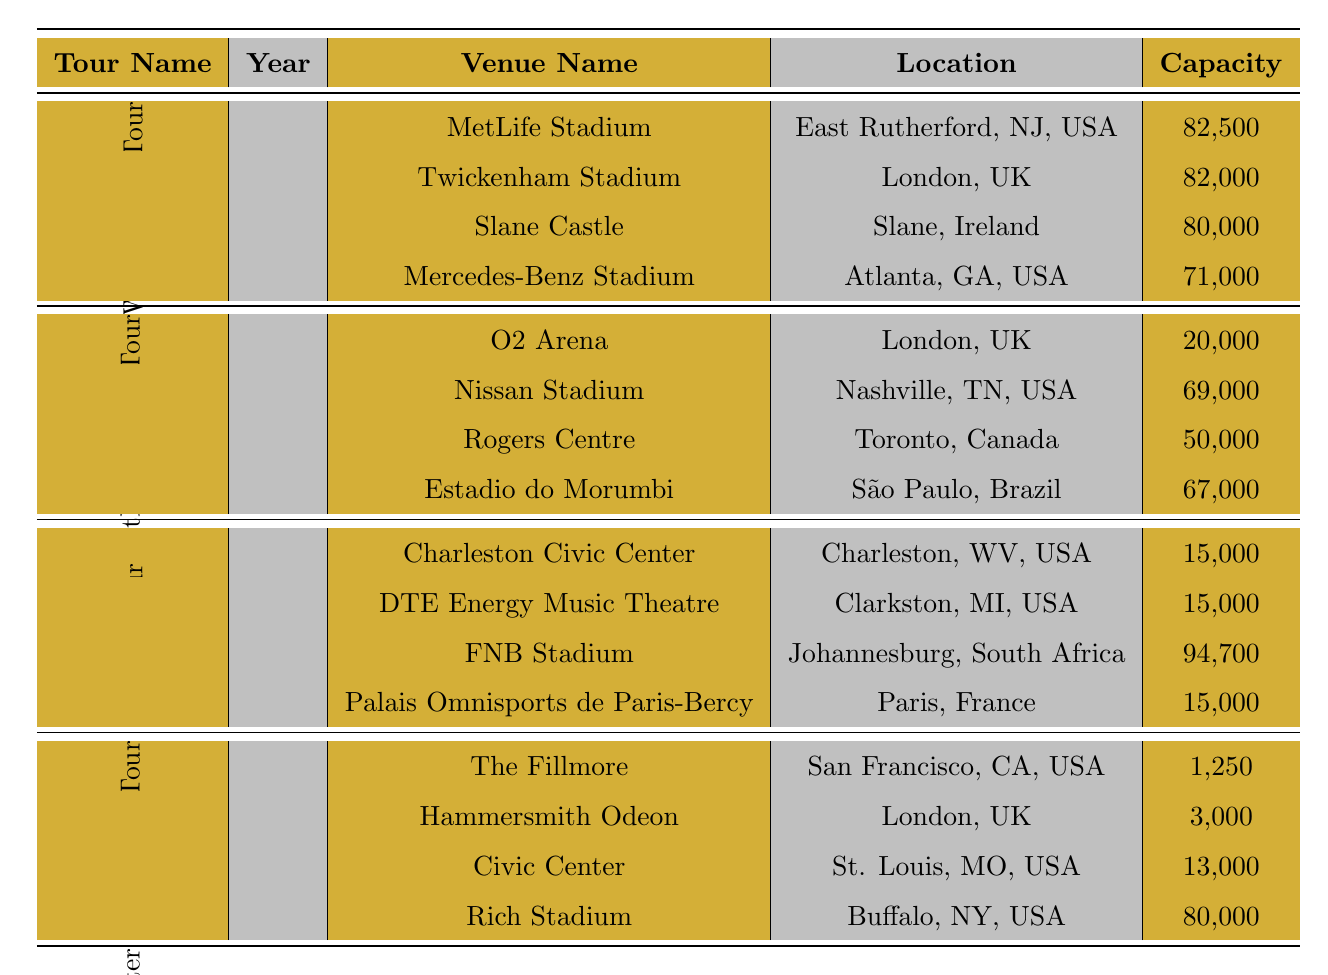What's the maximum venue capacity from the WorldWired Tour? The venues listed under the WorldWired Tour are MetLife Stadium (82,500), Twickenham Stadium (82,000), Slane Castle (80,000), and Mercedes-Benz Stadium (71,000). The highest capacity among these is MetLife Stadium at 82,500.
Answer: 82,500 Which tour had the least capacity at a single venue? The Master of Puppets Tour had The Fillmore with a capacity of 1,250, which is the lowest of all the venues listed in the table.
Answer: 1,250 What is the total capacity of all venues in the Death Magnetic Tour? The venues for the Death Magnetic Tour and their capacities are: O2 Arena (20,000), Nissan Stadium (69,000), Rogers Centre (50,000), and Estadio do Morumbi (67,000). Adding these values gives: 20,000 + 69,000 + 50,000 + 67,000 = 206,000.
Answer: 206,000 Is there a venue in the Load Tour that has a higher capacity than any venue in the Death Magnetic Tour? The highest capacity in the Load Tour is FNB Stadium at 94,700, which is greater than the highest capacity in the Death Magnetic Tour, which is Nissan Stadium at 69,000. Thus, yes, there is a venue in the Load Tour with a higher capacity.
Answer: Yes What is the average venue capacity across all tours listed? To find the average, first, we sum the capacities of all venues: 82,500 (WorldWired Tour) + 82,000 (WorldWired) + 80,000 (WorldWired) + 71,000 (WorldWired) + 20,000 (Death Magnetic) + 69,000 (Death Magnetic) + 50,000 (Death Magnetic) + 67,000 (Death Magnetic) + 15,000 (Load) + 15,000 (Load) + 94,700 (Load) + 15,000 (Load) + 1,250 (Master of Puppets) + 3,000 (Master of Puppets) + 13,000 (Master of Puppets) + 80,000 (Master of Puppets) = 670,450. There are 16 venues, so the average is 670,450 / 16 = 41,903.125, rounding down gives 41,903.
Answer: 41,903 Which city's venues had the highest capacities overall? In the list, San Francisco (The Fillmore at 1,250) is the lowest capacity, while FNB Stadium in Johannesburg has the highest capacity at 94,700 among other venues. However, New York (MetLife Stadium at 82,500) is also high. Since Johannesburg has the highest single venue capacity (FNB Stadium at 94,700), it can be concluded that its venue had the highest capacity overall.
Answer: Johannesburg How many venues are located in the UK across all tours? In the table, there are 4 venues in the UK: Twickenham Stadium (WorldWired Tour), O2 Arena (Death Magnetic Tour), Hammersmith Odeon (Master of Puppets Tour). So there are 3 venues located in the UK.
Answer: 3 Which tour contained the most number of venues? Each tour has 4 venues listed, making them identical in terms of venue count. Therefore, there is no single tour that contains more than the others.
Answer: All tours have the same number of venues (4) 